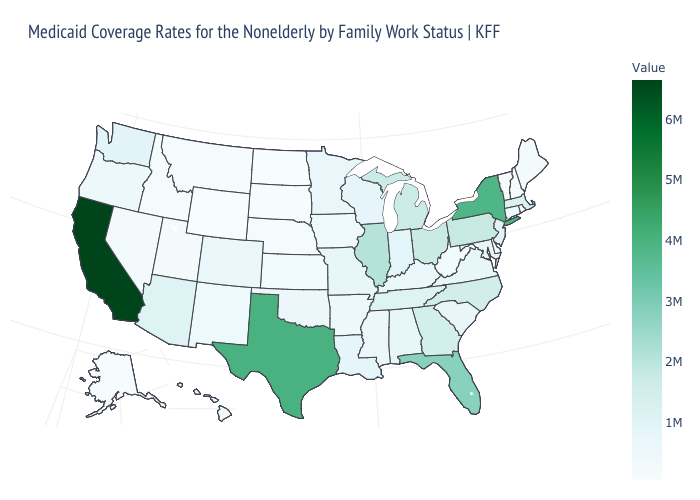Among the states that border Nebraska , does Colorado have the lowest value?
Concise answer only. No. Among the states that border Michigan , does Wisconsin have the lowest value?
Short answer required. Yes. Does South Carolina have a lower value than Wyoming?
Quick response, please. No. Does Arkansas have the highest value in the South?
Give a very brief answer. No. Does Illinois have the highest value in the MidWest?
Quick response, please. Yes. Does Pennsylvania have the lowest value in the Northeast?
Keep it brief. No. Does the map have missing data?
Keep it brief. No. 